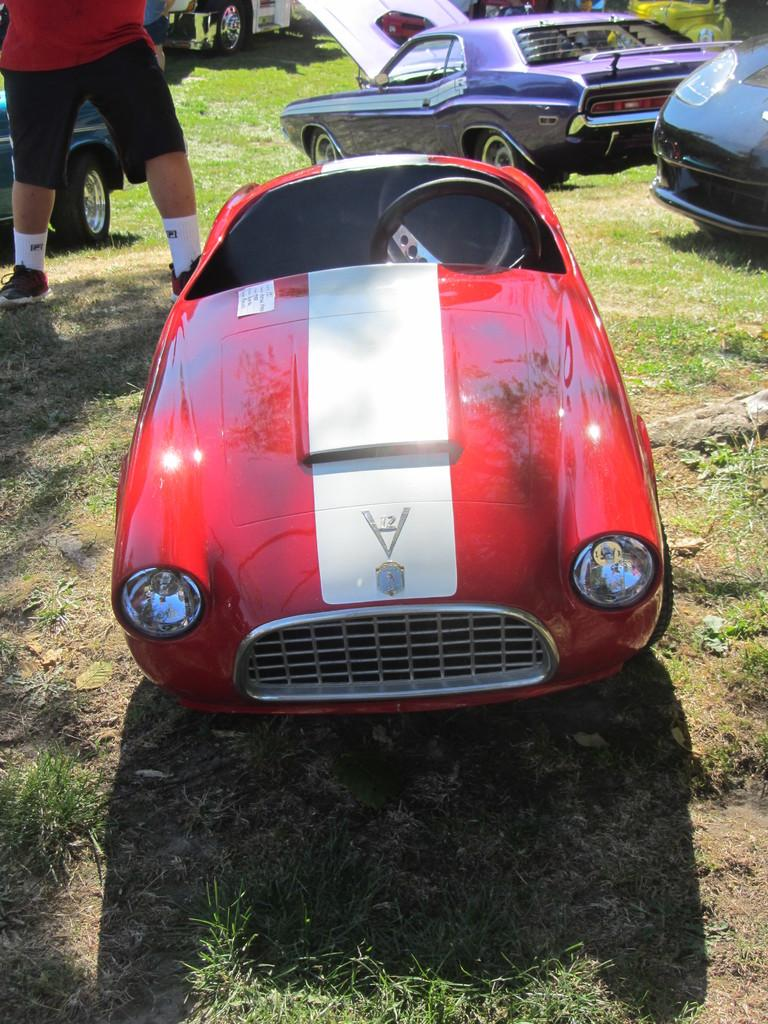What type of objects are present on the grassy surface in the image? There are toy vehicles of different colors in the image. What is the surface on which the vehicles are placed? The vehicles are on a grassy surface. Is there a person visible in the image? Yes, there is a person standing in the image. What clothing items is the person wearing? The person is wearing clothes, socks, and shoes. How many fish can be seen swimming in the grassy area in the image? There are no fish present in the image; it features toy vehicles on a grassy surface and a person standing nearby. 